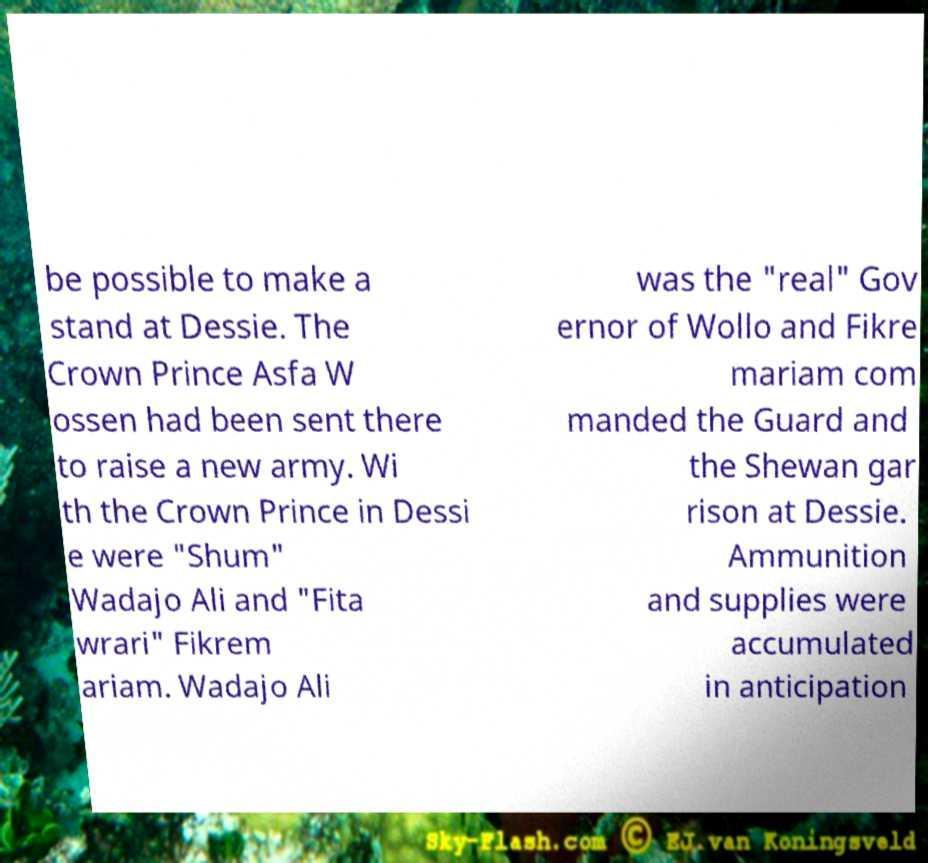Could you extract and type out the text from this image? be possible to make a stand at Dessie. The Crown Prince Asfa W ossen had been sent there to raise a new army. Wi th the Crown Prince in Dessi e were "Shum" Wadajo Ali and "Fita wrari" Fikrem ariam. Wadajo Ali was the "real" Gov ernor of Wollo and Fikre mariam com manded the Guard and the Shewan gar rison at Dessie. Ammunition and supplies were accumulated in anticipation 